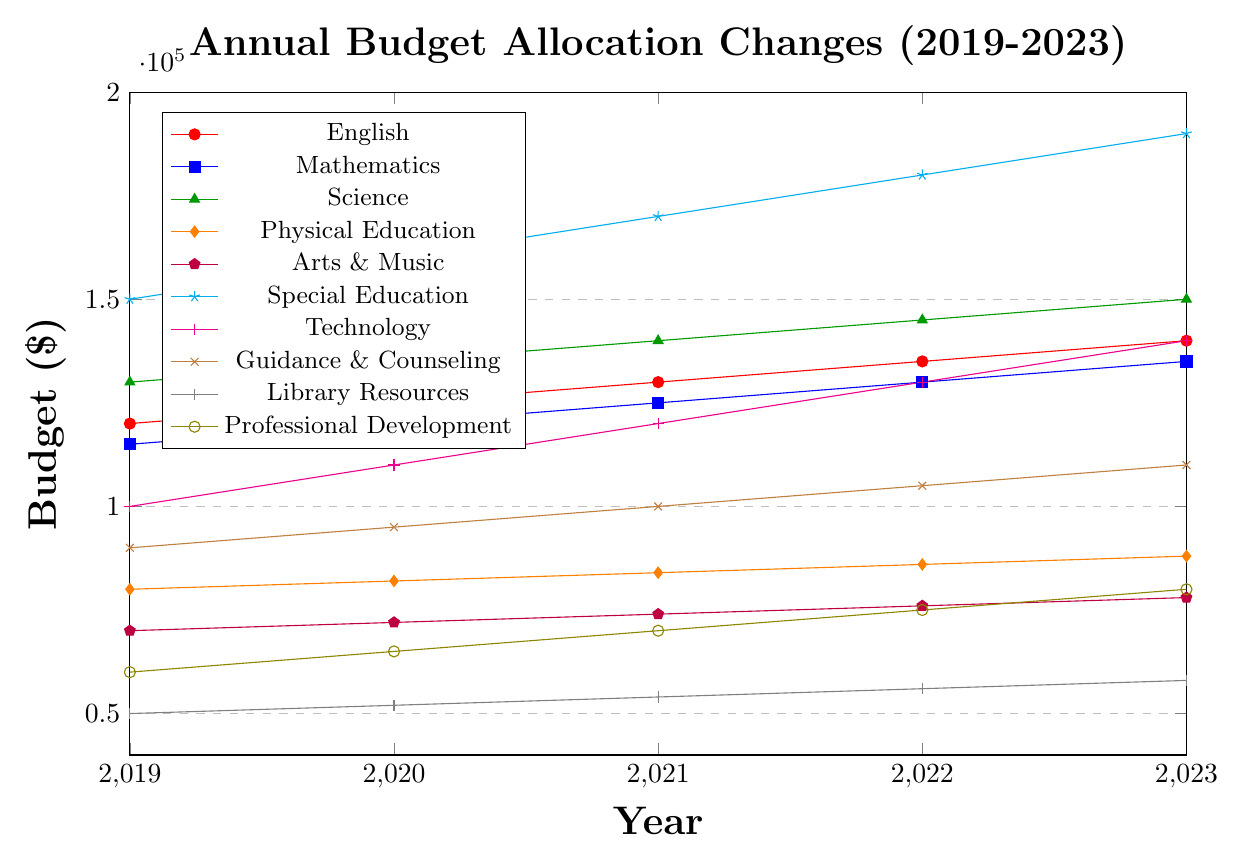Which department had the highest budget allocation in 2023? According to the chart, the Special Education department had the highest budget allocation in 2023 with $190,000.
Answer: Special Education Which department experienced the largest total increase in budget from 2019 to 2023? By calculating the total increase for each department, Special Education saw the largest increase, rising from $150,000 in 2019 to $190,000 in 2023, a $40,000 increase.
Answer: Special Education Compare the budget allocation trends for English and Mathematics. What similarities do you observe? Both English and Mathematics departments show a consistent yearly increase of $5,000 each year from 2019 to 2023.
Answer: Both have consistent yearly increases of $5,000 Which department had the lowest budget allocation in 2021? From the chart, the Library Resources department had the lowest budget allocation in 2021 with $54,000.
Answer: Library Resources What was the average budget allocation for the Science department over the 5 years? Adding the budget values for Science from 2019 to 2023: (130,000 + 135,000 + 140,000 + 145,000 + 150,000) and dividing by 5 gives an average allocation of 140,000.
Answer: 140,000 By how much did the budget for Arts & Music increase from 2019 to 2023? The budget for Arts & Music went from $70,000 in 2019 to $78,000 in 2023, an increase of $8,000.
Answer: $8,000 Which departments were allocated budgets below $90,000 consistently for all five years? Checking each year's data, Arts & Music, Library Resources, and Professional Development had budgets consistently below $90,000.
Answer: Arts & Music, Library Resources, Professional Development Which department's budget increased by $10,000 each year? The Special Education department's budget increased from $150,000 in 2019 to $190,000 in 2023, with yearly increases of $10,000.
Answer: Special Education Between Technology and Guidance & Counseling, which had a higher average yearly budget allocation? Calculating the 5-year average for Technology: (100,000 + 110,000 + 120,000 + 130,000 + 140,000) gives an average of $120,000. For Guidance & Counseling: (90,000 + 95,000 + 100,000 + 105,000 + 110,000) gives an average of $100,000. Thus, Technology had a higher average.
Answer: Technology If the total budget of all departments in 2020 was $995,000, what was the percentage contribution of the Science department in 2020? The budget for Science in 2020 was $135,000. To find the percentage, (135,000 / 995,000) * 100% = 13.57%.
Answer: 13.57% 